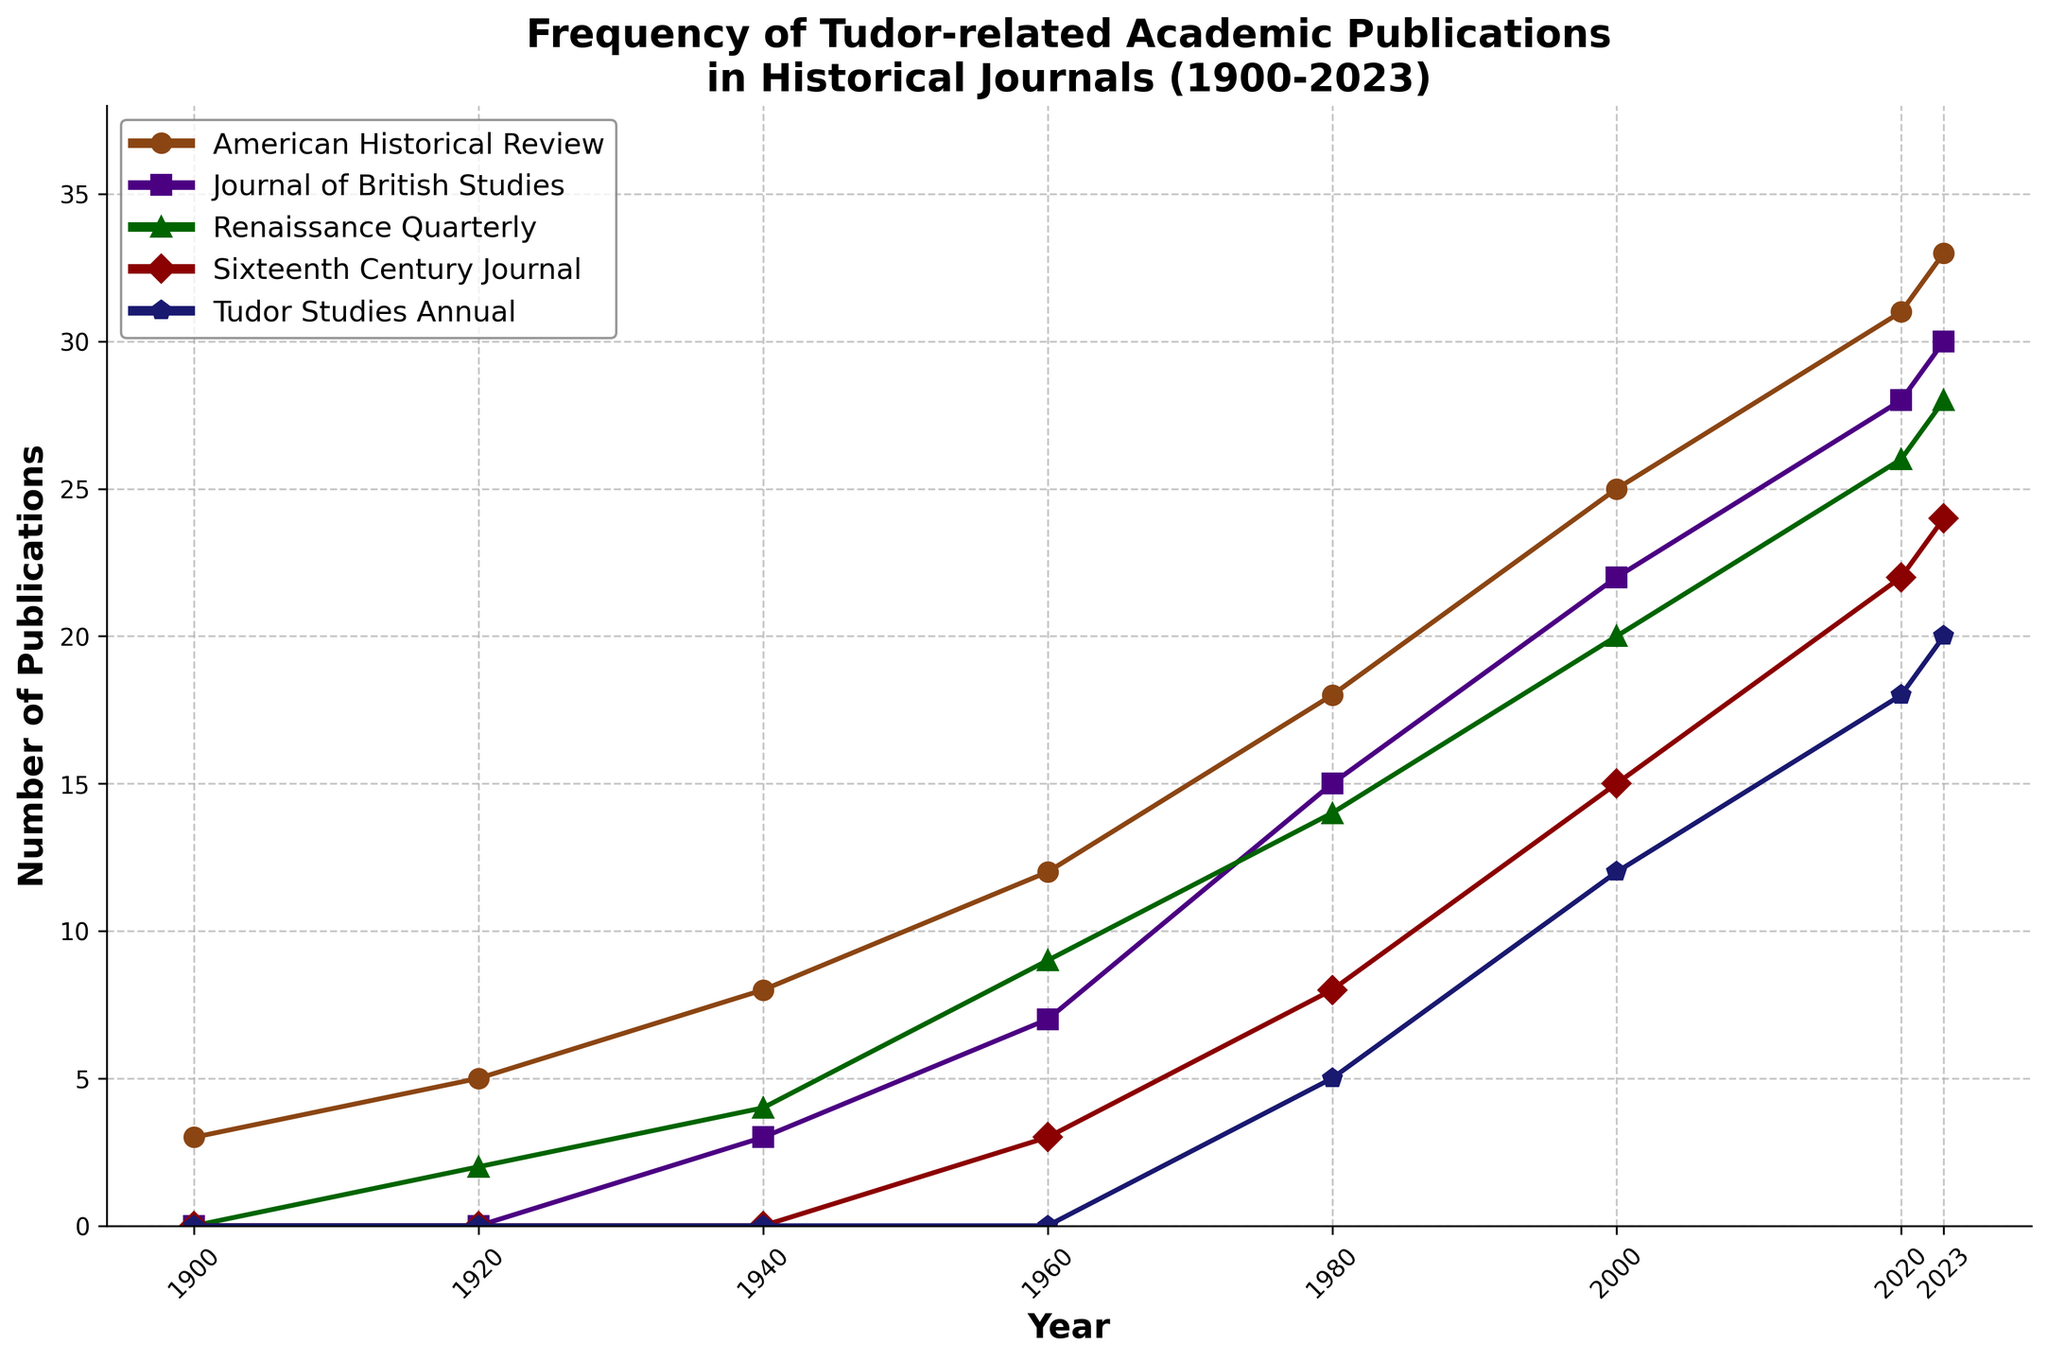What journal shows the highest frequency of Tudor-related publications in 2023? Look at the line representing the different journals for the year 2023. The line for the 'American Historical Review' is the highest in 2023.
Answer: American Historical Review Between 1960 and 2023, which journal has the steepest increase in Tudor-related publications? Compare the slope of each journal's line between 1960 and 2023. The 'American Historical Review' has the steepest increase, as it rises from 12 publications in 1960 to 33 publications in 2023.
Answer: American Historical Review In which decade did the 'Journal of British Studies' first publish more than 20 Tudor-related articles? Look at the 'Journal of British Studies' line and identify when it exceeds 20 articles. It first surpasses 20 articles in the year 2000.
Answer: 2000s How many Tudor-related articles did the 'Sixteenth Century Journal' publish in 1960 and 2023 combined? Refer to the data points for the 'Sixteenth Century Journal' in 1960 and 2023. In 1960, it published 3 articles, and in 2023, it published 24 articles. Summing these values gives 3 + 24 = 27.
Answer: 27 Which journal showed no publications of Tudor-related articles in 1920? Look at the data points for the year 1920 and identify the journal with 0 publications. The 'Sixteenth Century Journal' and 'Tudor Studies Annual' both had 0 publications.
Answer: Sixteenth Century Journal, Tudor Studies Annual By what percentage did the publications in 'Renaissance Quarterly' increase from 1980 to 2023? Identify the data points for 'Renaissance Quarterly' in 1980 (14) and 2023 (28). Calculate the percentage increase: ((28-14)/14) * 100.
Answer: 100% From 1940 to 2023, which journal had the smallest absolute increase in Tudor-related publications? Calculate the difference between 1940 and 2023 for each journal: 'American Historical Review' (33-8=25), 'Journal of British Studies' (30-3=27), 'Renaissance Quarterly' (28-4=24), 'Sixteenth Century Journal' (24-0=24), 'Tudor Studies Annual' (20-0=20). The 'Tudor Studies Annual' has the smallest increase of 20 publications.
Answer: Tudor Studies Annual In which year did 'Tudor Studies Annual' first appear in the data? Look at the first non-zero data point for 'Tudor Studies Annual'. It first appears in the year 1980.
Answer: 1980 Which journal had the most consistent increase in Tudor-related publications from 1900 to 2023? Compare the trends of each journal and identify which has the most steady upward growth. The 'American Historical Review' shows a consistent increase across the years.
Answer: American Historical Review What is the average number of Tudor-related publications in the 'Journal of British Studies' across all available years? Add the publication counts for the 'Journal of British Studies' across all years (0 + 0 + 3 + 7 + 15 + 22 + 28 + 30 = 105) and divide by the number of data points (8). 105 / 8 = 13.125.
Answer: 13.125 